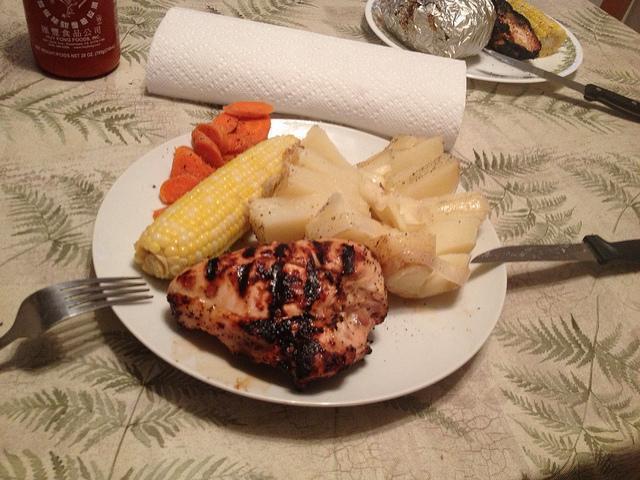What was used to cook the meat and potatoes of the dish?
Indicate the correct choice and explain in the format: 'Answer: answer
Rationale: rationale.'
Options: Stove, oven, air fryer, grill. Answer: grill.
Rationale: The chicken has grill marks. 